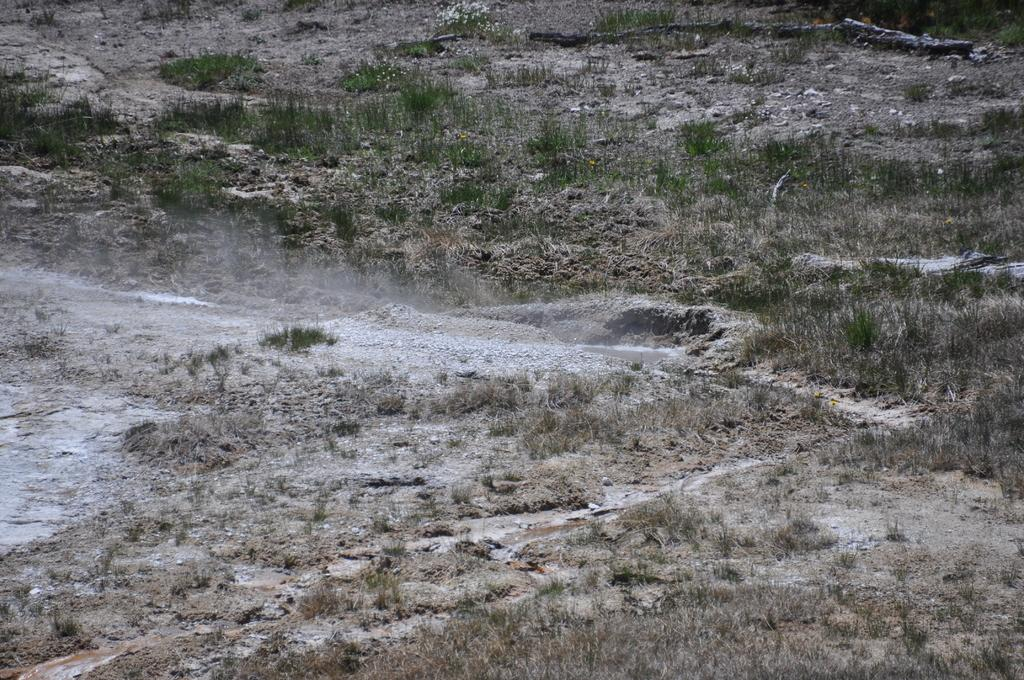What type of vegetation is present on the land in the image? There is grass on the land in the image. How many teeth can be seen in the image? There are no teeth present in the image; it features grass on the land. What type of clover is growing in the image? There is no clover present in the image; it only features grass on the land. 